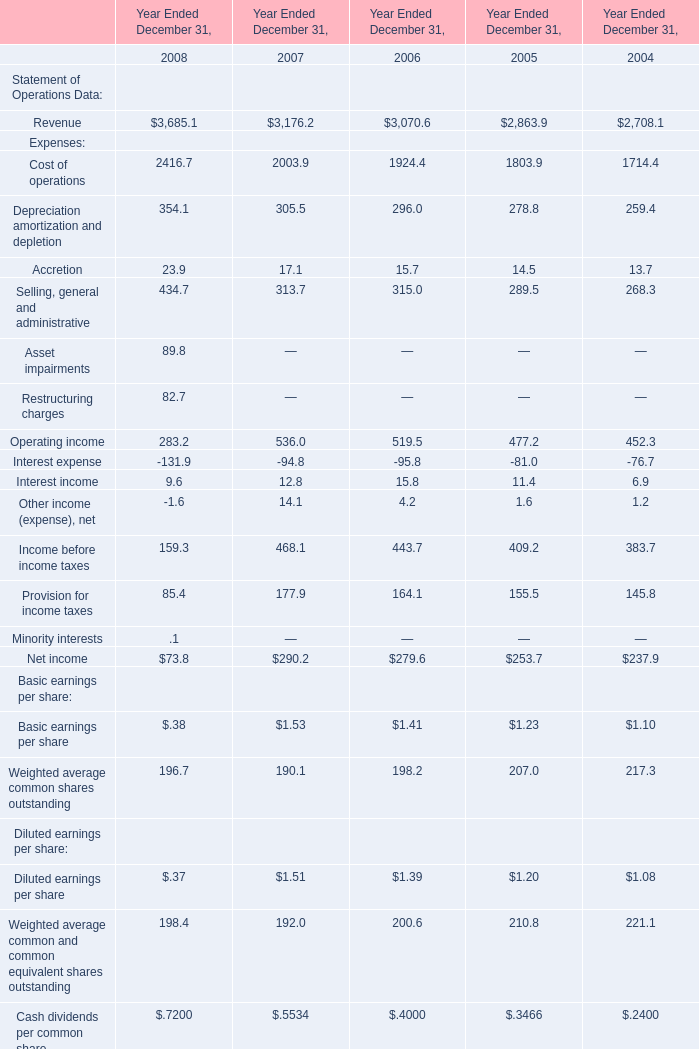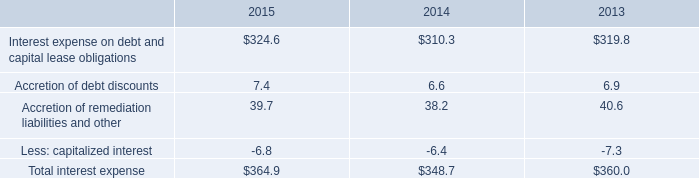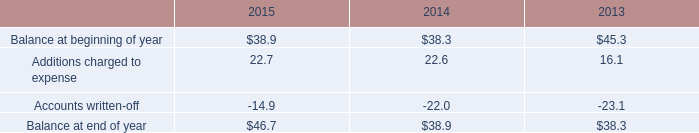in december 2015 what was the ratio of the restricted cash and marketable securities to the allowance for doubtful accounts 
Computations: (100.3 / 46.7)
Answer: 2.14775. 